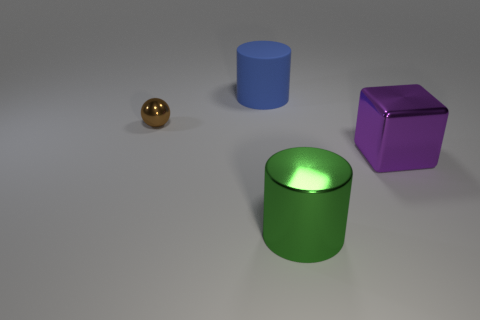Is the shape of the big thing behind the small metal thing the same as  the purple metal thing?
Offer a terse response. No. There is a large object that is left of the large cylinder that is in front of the thing that is behind the brown metal thing; what shape is it?
Offer a terse response. Cylinder. What is the material of the thing that is on the right side of the small brown ball and behind the purple shiny block?
Keep it short and to the point. Rubber. Is the number of big metal things less than the number of objects?
Give a very brief answer. Yes. There is a large purple thing; does it have the same shape as the thing that is left of the blue thing?
Your answer should be compact. No. Is the size of the metal thing that is to the left of the blue object the same as the large green shiny object?
Provide a succinct answer. No. The matte thing that is the same size as the purple cube is what shape?
Your answer should be very brief. Cylinder. Is the shape of the small shiny object the same as the green metallic thing?
Keep it short and to the point. No. What number of other things have the same shape as the large green metallic thing?
Offer a terse response. 1. How many large things are to the right of the matte cylinder?
Keep it short and to the point. 2. 